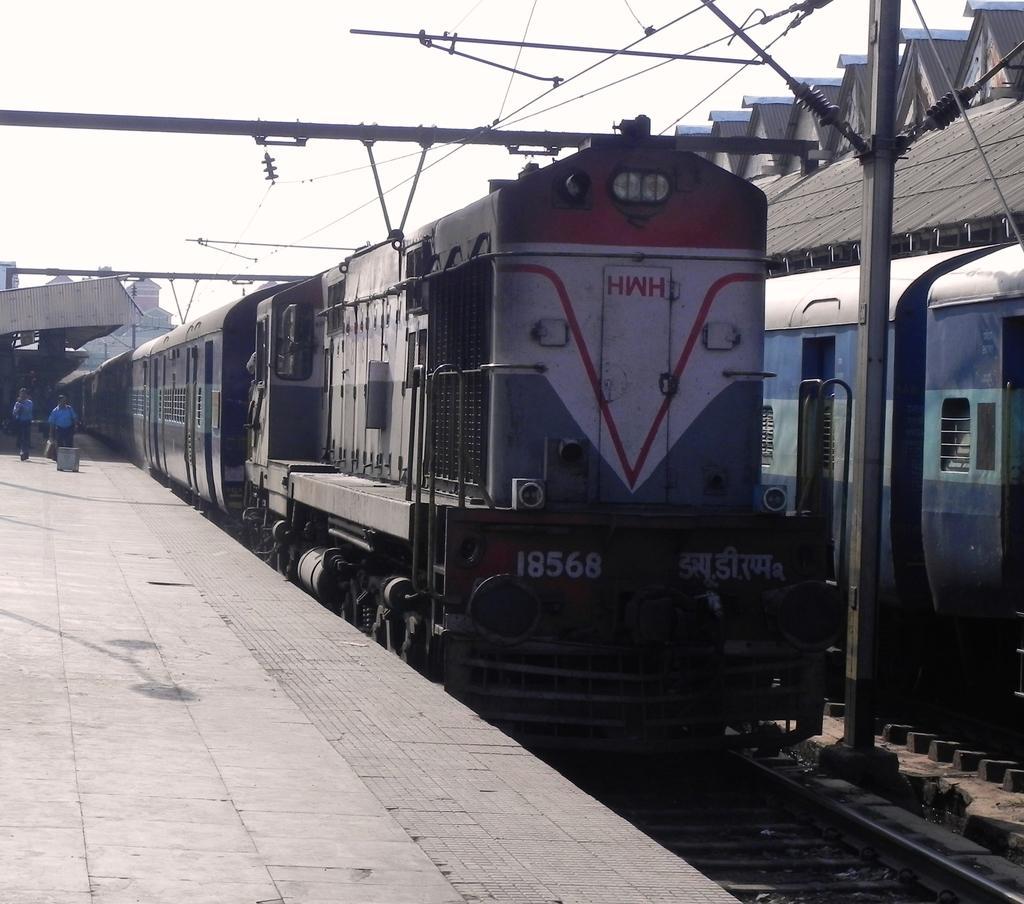Could you give a brief overview of what you see in this image? In the image there are two trains on a railway track and beside them there is a platform and there are few people standing on the platform, in between the trains there is a pole and there are many wires attached to that pole. 